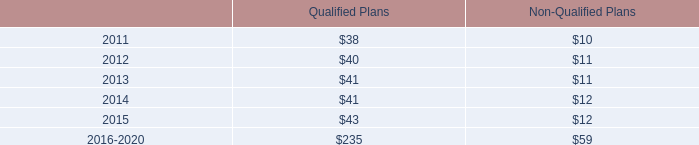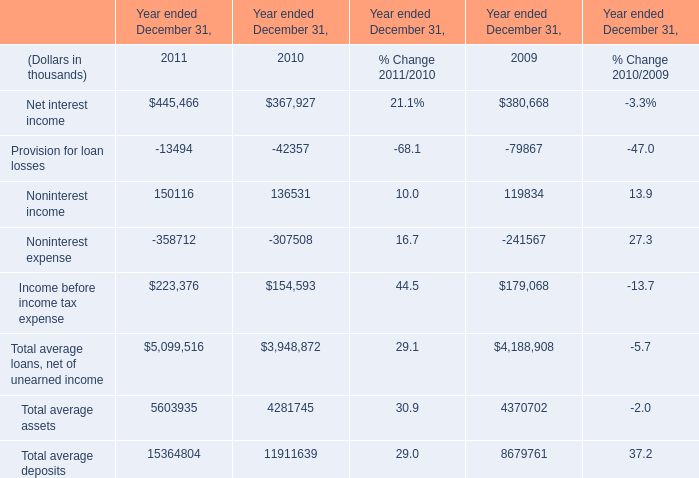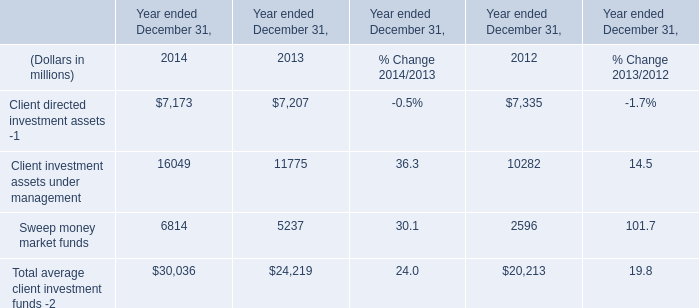What's the average of Sweep money market funds of Year ended December 31, 2012, and Provision for loan losses of Year ended December 31, 2009 ? 
Computations: ((2596.0 + 79867.0) / 2)
Answer: 41231.5. 